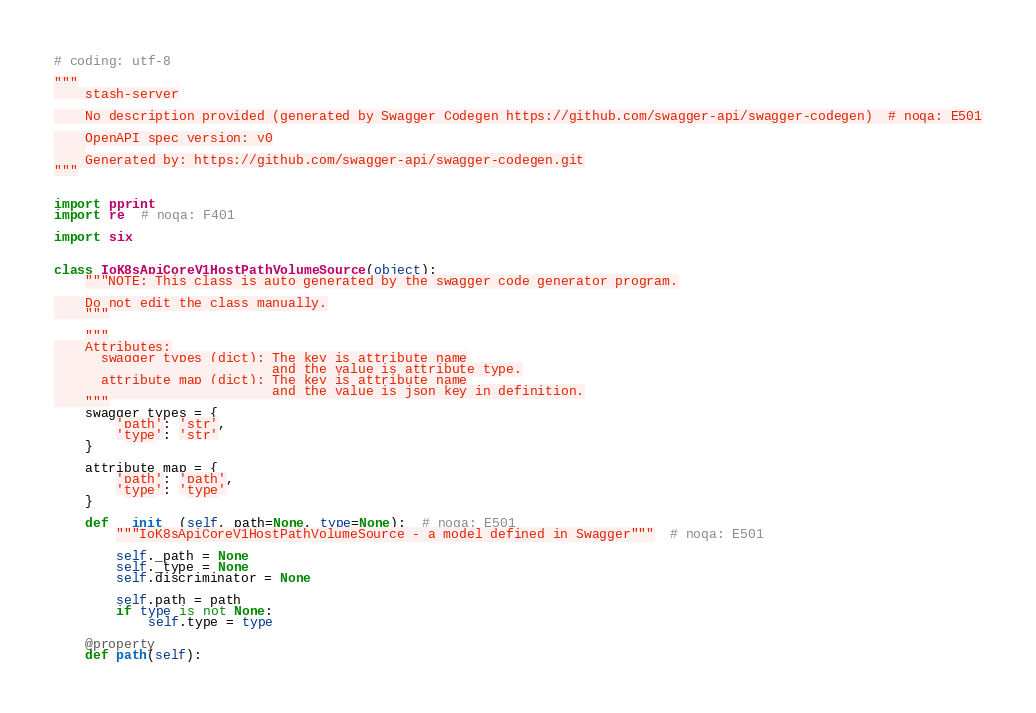Convert code to text. <code><loc_0><loc_0><loc_500><loc_500><_Python_># coding: utf-8

"""
    stash-server

    No description provided (generated by Swagger Codegen https://github.com/swagger-api/swagger-codegen)  # noqa: E501

    OpenAPI spec version: v0
    
    Generated by: https://github.com/swagger-api/swagger-codegen.git
"""


import pprint
import re  # noqa: F401

import six


class IoK8sApiCoreV1HostPathVolumeSource(object):
    """NOTE: This class is auto generated by the swagger code generator program.

    Do not edit the class manually.
    """

    """
    Attributes:
      swagger_types (dict): The key is attribute name
                            and the value is attribute type.
      attribute_map (dict): The key is attribute name
                            and the value is json key in definition.
    """
    swagger_types = {
        'path': 'str',
        'type': 'str'
    }

    attribute_map = {
        'path': 'path',
        'type': 'type'
    }

    def __init__(self, path=None, type=None):  # noqa: E501
        """IoK8sApiCoreV1HostPathVolumeSource - a model defined in Swagger"""  # noqa: E501

        self._path = None
        self._type = None
        self.discriminator = None

        self.path = path
        if type is not None:
            self.type = type

    @property
    def path(self):</code> 